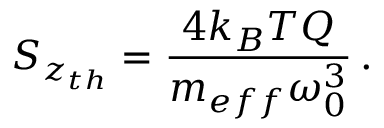<formula> <loc_0><loc_0><loc_500><loc_500>S _ { z _ { t h } } = \frac { 4 k _ { B } T Q } { m _ { e f f } \omega _ { 0 } ^ { 3 } } \, .</formula> 